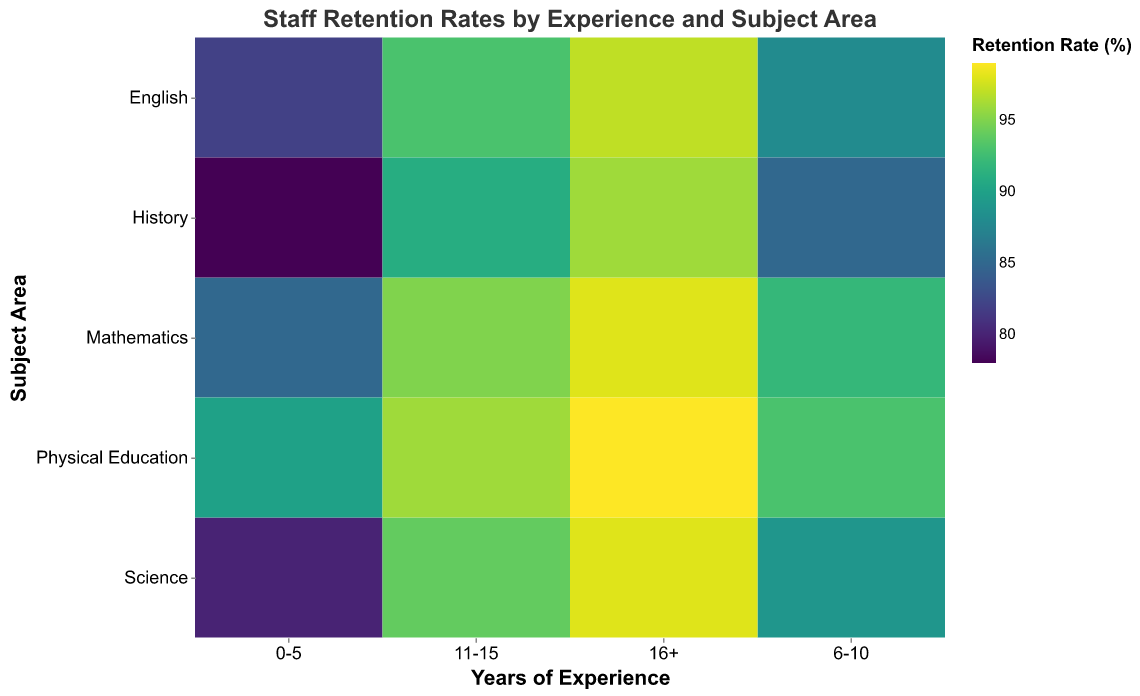What is the title of the plot? The title of the plot is displayed at the top center of the figure in large text. Refer to the visual to read the exact words.
Answer: Staff Retention Rates by Experience and Subject Area Which subject area has the highest retention rate for the 0-5 years of experience group? Look at the 0-5 years of experience vertical axis and identify which subject area has the darkest color indicated by the legend.
Answer: Physical Education What is the color scale used to represent the retention rates? Refer to the color legend on the plot which shows a gradient scheme to indicate retention rates from lower to higher values.
Answer: Viridis Compare the retention rates for Mathematics and English in the 16+ years of experience group. Identify both Mathematics and English in the 16+ years block and compare their corresponding colors/values shown in the legend.
Answer: Mathematics: 98, English: 97 Which years of experience group shows the highest overall retention rates across all subject areas? Identify the years of experience group with the most uniformly darkest color blocks, indicating the highest retention rates.
Answer: 16+ On average, how do retention rates change as years of experience increase across all subjects? Compare the retention rates for each subject across different years of experience blocks, notice the general trend in color changes.
Answer: Retention rates increase with more years of experience Do any subject areas have a consistent retention rate trend over different years of experience? Check each subject area from 0-5 years to 16+ years and see if all retention rates are increasing, decreasing, or mixed.
Answer: All subjects show increasing retention rates How does the retention rate of Science compare with Physical Education in the 11-15 years of experience group? Locate Science and Physical Education in the 11-15 years block and compare their retention rates.
Answer: Science: 94, Physical Education: 96 What is the lowest retention rate observed in the plot and for which subject and experience group? Identify the lightest color blocks that represent the lowest retention rates based on the legend, then note the relevant subject area and experience block.
Answer: History, 0-5 years, 78% Which experience group has the highest retention rate for English? Examine retention rates for English across all experience groups and identify the group with the darkest color or highest value.
Answer: 16+ years, 97% 